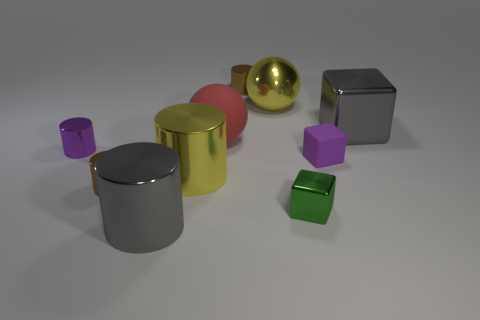Subtract all large gray metal cylinders. How many cylinders are left? 4 Subtract all gray cylinders. How many cylinders are left? 4 Subtract all purple cylinders. Subtract all cyan blocks. How many cylinders are left? 4 Subtract all blocks. How many objects are left? 7 Subtract 0 cyan cylinders. How many objects are left? 10 Subtract all tiny brown metallic cubes. Subtract all large red rubber things. How many objects are left? 9 Add 2 gray blocks. How many gray blocks are left? 3 Add 1 small brown metal cylinders. How many small brown metal cylinders exist? 3 